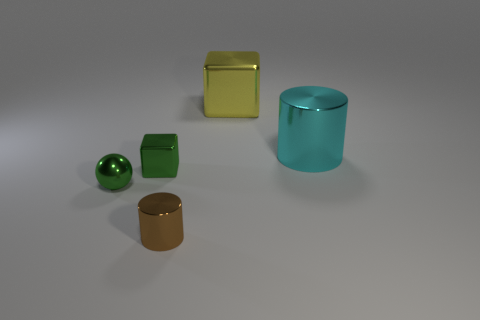What is the large cyan object made of?
Provide a succinct answer. Metal. What number of rubber things are either tiny green spheres or cyan things?
Your response must be concise. 0. Is the number of brown metal objects that are on the right side of the big cylinder less than the number of tiny metal blocks that are on the left side of the small cylinder?
Ensure brevity in your answer.  Yes. Are there any tiny brown shiny things that are on the right side of the green object that is behind the thing left of the small shiny block?
Make the answer very short. Yes. What material is the block that is the same color as the metallic sphere?
Your response must be concise. Metal. Do the big yellow shiny object right of the small cylinder and the big object on the right side of the yellow object have the same shape?
Give a very brief answer. No. What material is the cyan object that is the same size as the yellow cube?
Offer a terse response. Metal. Do the block that is behind the tiny green block and the small brown cylinder in front of the cyan shiny cylinder have the same material?
Keep it short and to the point. Yes. There is another metal thing that is the same size as the yellow metallic object; what shape is it?
Provide a short and direct response. Cylinder. What number of other objects are there of the same color as the ball?
Make the answer very short. 1. 